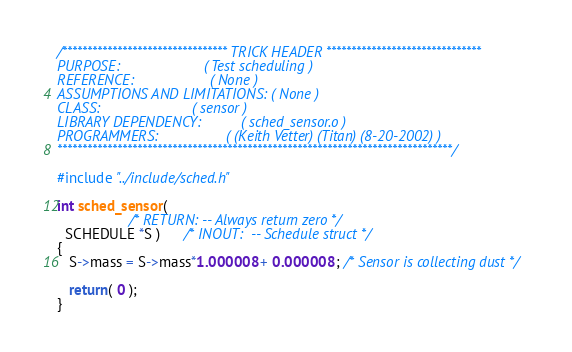<code> <loc_0><loc_0><loc_500><loc_500><_C_>/********************************* TRICK HEADER *******************************
PURPOSE:                     ( Test scheduling )
REFERENCE:                   ( None )
ASSUMPTIONS AND LIMITATIONS: ( None )
CLASS:                       ( sensor )
LIBRARY DEPENDENCY:          ( sched_sensor.o )
PROGRAMMERS:                 ( (Keith Vetter) (Titan) (8-20-2002) )
*******************************************************************************/

#include "../include/sched.h"

int sched_sensor(
                  /* RETURN: -- Always return zero */
  SCHEDULE *S )      /* INOUT:  -- Schedule struct */
{
   S->mass = S->mass*1.000008 + 0.000008 ; /* Sensor is collecting dust */

   return( 0 );
}
</code> 